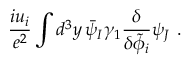<formula> <loc_0><loc_0><loc_500><loc_500>\frac { i u _ { i } } { e ^ { 2 } } \int d ^ { 3 } y \, \bar { \psi } _ { I } \gamma _ { 1 } \frac { \delta } { \delta \tilde { \phi } _ { i } } \psi _ { J } \ .</formula> 